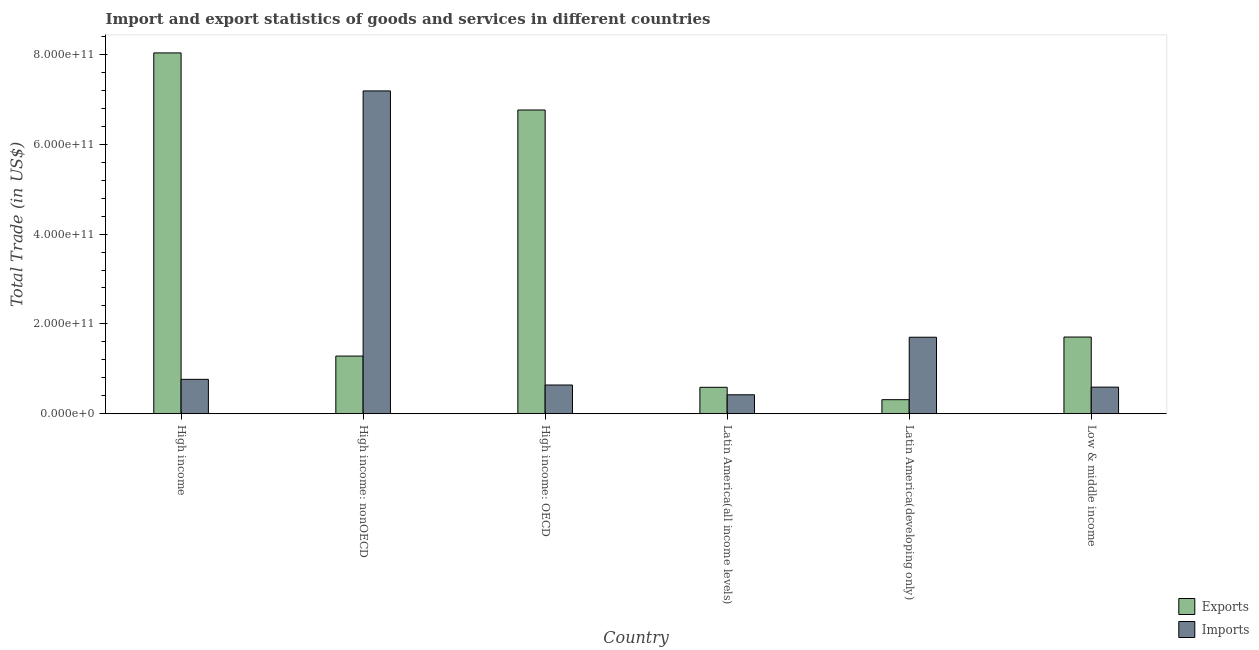Are the number of bars per tick equal to the number of legend labels?
Make the answer very short. Yes. Are the number of bars on each tick of the X-axis equal?
Provide a short and direct response. Yes. What is the imports of goods and services in Latin America(all income levels)?
Your response must be concise. 4.22e+1. Across all countries, what is the maximum export of goods and services?
Your answer should be compact. 8.03e+11. Across all countries, what is the minimum imports of goods and services?
Offer a very short reply. 4.22e+1. In which country was the imports of goods and services maximum?
Make the answer very short. High income: nonOECD. In which country was the imports of goods and services minimum?
Offer a very short reply. Latin America(all income levels). What is the total imports of goods and services in the graph?
Make the answer very short. 1.13e+12. What is the difference between the imports of goods and services in Latin America(all income levels) and that in Latin America(developing only)?
Offer a terse response. -1.28e+11. What is the difference between the export of goods and services in Latin America(developing only) and the imports of goods and services in High income: nonOECD?
Your answer should be compact. -6.87e+11. What is the average imports of goods and services per country?
Your response must be concise. 1.89e+11. What is the difference between the export of goods and services and imports of goods and services in High income?
Provide a succinct answer. 7.27e+11. What is the ratio of the imports of goods and services in High income: nonOECD to that in Low & middle income?
Give a very brief answer. 12.13. Is the imports of goods and services in High income less than that in Low & middle income?
Give a very brief answer. No. Is the difference between the export of goods and services in High income and High income: nonOECD greater than the difference between the imports of goods and services in High income and High income: nonOECD?
Offer a terse response. Yes. What is the difference between the highest and the second highest imports of goods and services?
Ensure brevity in your answer.  5.48e+11. What is the difference between the highest and the lowest export of goods and services?
Your answer should be compact. 7.72e+11. In how many countries, is the export of goods and services greater than the average export of goods and services taken over all countries?
Offer a terse response. 2. What does the 1st bar from the left in High income: nonOECD represents?
Give a very brief answer. Exports. What does the 2nd bar from the right in Latin America(developing only) represents?
Offer a very short reply. Exports. How many bars are there?
Keep it short and to the point. 12. How many countries are there in the graph?
Make the answer very short. 6. What is the difference between two consecutive major ticks on the Y-axis?
Your answer should be compact. 2.00e+11. Does the graph contain grids?
Your response must be concise. No. Where does the legend appear in the graph?
Your response must be concise. Bottom right. How many legend labels are there?
Give a very brief answer. 2. How are the legend labels stacked?
Make the answer very short. Vertical. What is the title of the graph?
Offer a terse response. Import and export statistics of goods and services in different countries. Does "Private consumption" appear as one of the legend labels in the graph?
Keep it short and to the point. No. What is the label or title of the X-axis?
Provide a succinct answer. Country. What is the label or title of the Y-axis?
Offer a terse response. Total Trade (in US$). What is the Total Trade (in US$) in Exports in High income?
Your answer should be very brief. 8.03e+11. What is the Total Trade (in US$) in Imports in High income?
Your response must be concise. 7.66e+1. What is the Total Trade (in US$) in Exports in High income: nonOECD?
Offer a very short reply. 1.28e+11. What is the Total Trade (in US$) in Imports in High income: nonOECD?
Your answer should be very brief. 7.19e+11. What is the Total Trade (in US$) of Exports in High income: OECD?
Offer a very short reply. 6.76e+11. What is the Total Trade (in US$) of Imports in High income: OECD?
Make the answer very short. 6.40e+1. What is the Total Trade (in US$) in Exports in Latin America(all income levels)?
Your answer should be very brief. 5.89e+1. What is the Total Trade (in US$) in Imports in Latin America(all income levels)?
Your answer should be compact. 4.22e+1. What is the Total Trade (in US$) in Exports in Latin America(developing only)?
Give a very brief answer. 3.13e+1. What is the Total Trade (in US$) of Imports in Latin America(developing only)?
Ensure brevity in your answer.  1.70e+11. What is the Total Trade (in US$) in Exports in Low & middle income?
Provide a short and direct response. 1.71e+11. What is the Total Trade (in US$) of Imports in Low & middle income?
Your answer should be very brief. 5.92e+1. Across all countries, what is the maximum Total Trade (in US$) of Exports?
Provide a short and direct response. 8.03e+11. Across all countries, what is the maximum Total Trade (in US$) of Imports?
Offer a very short reply. 7.19e+11. Across all countries, what is the minimum Total Trade (in US$) of Exports?
Offer a terse response. 3.13e+1. Across all countries, what is the minimum Total Trade (in US$) of Imports?
Your response must be concise. 4.22e+1. What is the total Total Trade (in US$) of Exports in the graph?
Your response must be concise. 1.87e+12. What is the total Total Trade (in US$) of Imports in the graph?
Your answer should be compact. 1.13e+12. What is the difference between the Total Trade (in US$) in Exports in High income and that in High income: nonOECD?
Your answer should be very brief. 6.75e+11. What is the difference between the Total Trade (in US$) in Imports in High income and that in High income: nonOECD?
Keep it short and to the point. -6.42e+11. What is the difference between the Total Trade (in US$) of Exports in High income and that in High income: OECD?
Ensure brevity in your answer.  1.27e+11. What is the difference between the Total Trade (in US$) of Imports in High income and that in High income: OECD?
Offer a terse response. 1.26e+1. What is the difference between the Total Trade (in US$) of Exports in High income and that in Latin America(all income levels)?
Make the answer very short. 7.44e+11. What is the difference between the Total Trade (in US$) in Imports in High income and that in Latin America(all income levels)?
Your answer should be compact. 3.44e+1. What is the difference between the Total Trade (in US$) in Exports in High income and that in Latin America(developing only)?
Keep it short and to the point. 7.72e+11. What is the difference between the Total Trade (in US$) of Imports in High income and that in Latin America(developing only)?
Keep it short and to the point. -9.38e+1. What is the difference between the Total Trade (in US$) in Exports in High income and that in Low & middle income?
Keep it short and to the point. 6.33e+11. What is the difference between the Total Trade (in US$) in Imports in High income and that in Low & middle income?
Your answer should be compact. 1.73e+1. What is the difference between the Total Trade (in US$) of Exports in High income: nonOECD and that in High income: OECD?
Offer a terse response. -5.48e+11. What is the difference between the Total Trade (in US$) of Imports in High income: nonOECD and that in High income: OECD?
Offer a terse response. 6.55e+11. What is the difference between the Total Trade (in US$) in Exports in High income: nonOECD and that in Latin America(all income levels)?
Keep it short and to the point. 6.95e+1. What is the difference between the Total Trade (in US$) of Imports in High income: nonOECD and that in Latin America(all income levels)?
Your response must be concise. 6.76e+11. What is the difference between the Total Trade (in US$) in Exports in High income: nonOECD and that in Latin America(developing only)?
Make the answer very short. 9.71e+1. What is the difference between the Total Trade (in US$) of Imports in High income: nonOECD and that in Latin America(developing only)?
Your answer should be compact. 5.48e+11. What is the difference between the Total Trade (in US$) of Exports in High income: nonOECD and that in Low & middle income?
Offer a very short reply. -4.24e+1. What is the difference between the Total Trade (in US$) in Imports in High income: nonOECD and that in Low & middle income?
Give a very brief answer. 6.59e+11. What is the difference between the Total Trade (in US$) of Exports in High income: OECD and that in Latin America(all income levels)?
Provide a short and direct response. 6.17e+11. What is the difference between the Total Trade (in US$) of Imports in High income: OECD and that in Latin America(all income levels)?
Ensure brevity in your answer.  2.18e+1. What is the difference between the Total Trade (in US$) of Exports in High income: OECD and that in Latin America(developing only)?
Provide a short and direct response. 6.45e+11. What is the difference between the Total Trade (in US$) of Imports in High income: OECD and that in Latin America(developing only)?
Give a very brief answer. -1.06e+11. What is the difference between the Total Trade (in US$) of Exports in High income: OECD and that in Low & middle income?
Offer a terse response. 5.05e+11. What is the difference between the Total Trade (in US$) of Imports in High income: OECD and that in Low & middle income?
Your answer should be compact. 4.72e+09. What is the difference between the Total Trade (in US$) in Exports in Latin America(all income levels) and that in Latin America(developing only)?
Provide a succinct answer. 2.76e+1. What is the difference between the Total Trade (in US$) in Imports in Latin America(all income levels) and that in Latin America(developing only)?
Ensure brevity in your answer.  -1.28e+11. What is the difference between the Total Trade (in US$) of Exports in Latin America(all income levels) and that in Low & middle income?
Your answer should be compact. -1.12e+11. What is the difference between the Total Trade (in US$) of Imports in Latin America(all income levels) and that in Low & middle income?
Give a very brief answer. -1.70e+1. What is the difference between the Total Trade (in US$) of Exports in Latin America(developing only) and that in Low & middle income?
Provide a short and direct response. -1.39e+11. What is the difference between the Total Trade (in US$) in Imports in Latin America(developing only) and that in Low & middle income?
Offer a very short reply. 1.11e+11. What is the difference between the Total Trade (in US$) of Exports in High income and the Total Trade (in US$) of Imports in High income: nonOECD?
Your answer should be compact. 8.46e+1. What is the difference between the Total Trade (in US$) in Exports in High income and the Total Trade (in US$) in Imports in High income: OECD?
Your answer should be very brief. 7.39e+11. What is the difference between the Total Trade (in US$) of Exports in High income and the Total Trade (in US$) of Imports in Latin America(all income levels)?
Keep it short and to the point. 7.61e+11. What is the difference between the Total Trade (in US$) in Exports in High income and the Total Trade (in US$) in Imports in Latin America(developing only)?
Keep it short and to the point. 6.33e+11. What is the difference between the Total Trade (in US$) in Exports in High income and the Total Trade (in US$) in Imports in Low & middle income?
Give a very brief answer. 7.44e+11. What is the difference between the Total Trade (in US$) of Exports in High income: nonOECD and the Total Trade (in US$) of Imports in High income: OECD?
Offer a very short reply. 6.44e+1. What is the difference between the Total Trade (in US$) in Exports in High income: nonOECD and the Total Trade (in US$) in Imports in Latin America(all income levels)?
Make the answer very short. 8.62e+1. What is the difference between the Total Trade (in US$) of Exports in High income: nonOECD and the Total Trade (in US$) of Imports in Latin America(developing only)?
Keep it short and to the point. -4.20e+1. What is the difference between the Total Trade (in US$) of Exports in High income: nonOECD and the Total Trade (in US$) of Imports in Low & middle income?
Your answer should be very brief. 6.91e+1. What is the difference between the Total Trade (in US$) of Exports in High income: OECD and the Total Trade (in US$) of Imports in Latin America(all income levels)?
Keep it short and to the point. 6.34e+11. What is the difference between the Total Trade (in US$) in Exports in High income: OECD and the Total Trade (in US$) in Imports in Latin America(developing only)?
Keep it short and to the point. 5.06e+11. What is the difference between the Total Trade (in US$) in Exports in High income: OECD and the Total Trade (in US$) in Imports in Low & middle income?
Provide a short and direct response. 6.17e+11. What is the difference between the Total Trade (in US$) in Exports in Latin America(all income levels) and the Total Trade (in US$) in Imports in Latin America(developing only)?
Offer a terse response. -1.11e+11. What is the difference between the Total Trade (in US$) in Exports in Latin America(all income levels) and the Total Trade (in US$) in Imports in Low & middle income?
Make the answer very short. -3.97e+08. What is the difference between the Total Trade (in US$) of Exports in Latin America(developing only) and the Total Trade (in US$) of Imports in Low & middle income?
Offer a very short reply. -2.79e+1. What is the average Total Trade (in US$) of Exports per country?
Provide a short and direct response. 3.11e+11. What is the average Total Trade (in US$) of Imports per country?
Make the answer very short. 1.89e+11. What is the difference between the Total Trade (in US$) in Exports and Total Trade (in US$) in Imports in High income?
Give a very brief answer. 7.27e+11. What is the difference between the Total Trade (in US$) in Exports and Total Trade (in US$) in Imports in High income: nonOECD?
Give a very brief answer. -5.90e+11. What is the difference between the Total Trade (in US$) in Exports and Total Trade (in US$) in Imports in High income: OECD?
Provide a short and direct response. 6.12e+11. What is the difference between the Total Trade (in US$) of Exports and Total Trade (in US$) of Imports in Latin America(all income levels)?
Your response must be concise. 1.66e+1. What is the difference between the Total Trade (in US$) in Exports and Total Trade (in US$) in Imports in Latin America(developing only)?
Ensure brevity in your answer.  -1.39e+11. What is the difference between the Total Trade (in US$) in Exports and Total Trade (in US$) in Imports in Low & middle income?
Ensure brevity in your answer.  1.12e+11. What is the ratio of the Total Trade (in US$) of Exports in High income to that in High income: nonOECD?
Your answer should be compact. 6.26. What is the ratio of the Total Trade (in US$) of Imports in High income to that in High income: nonOECD?
Provide a succinct answer. 0.11. What is the ratio of the Total Trade (in US$) of Exports in High income to that in High income: OECD?
Offer a terse response. 1.19. What is the ratio of the Total Trade (in US$) of Imports in High income to that in High income: OECD?
Keep it short and to the point. 1.2. What is the ratio of the Total Trade (in US$) in Exports in High income to that in Latin America(all income levels)?
Keep it short and to the point. 13.65. What is the ratio of the Total Trade (in US$) of Imports in High income to that in Latin America(all income levels)?
Offer a terse response. 1.81. What is the ratio of the Total Trade (in US$) of Exports in High income to that in Latin America(developing only)?
Offer a terse response. 25.66. What is the ratio of the Total Trade (in US$) of Imports in High income to that in Latin America(developing only)?
Keep it short and to the point. 0.45. What is the ratio of the Total Trade (in US$) of Exports in High income to that in Low & middle income?
Ensure brevity in your answer.  4.7. What is the ratio of the Total Trade (in US$) in Imports in High income to that in Low & middle income?
Your response must be concise. 1.29. What is the ratio of the Total Trade (in US$) in Exports in High income: nonOECD to that in High income: OECD?
Provide a short and direct response. 0.19. What is the ratio of the Total Trade (in US$) in Imports in High income: nonOECD to that in High income: OECD?
Give a very brief answer. 11.24. What is the ratio of the Total Trade (in US$) in Exports in High income: nonOECD to that in Latin America(all income levels)?
Your answer should be compact. 2.18. What is the ratio of the Total Trade (in US$) of Imports in High income: nonOECD to that in Latin America(all income levels)?
Make the answer very short. 17.03. What is the ratio of the Total Trade (in US$) in Exports in High income: nonOECD to that in Latin America(developing only)?
Offer a terse response. 4.1. What is the ratio of the Total Trade (in US$) in Imports in High income: nonOECD to that in Latin America(developing only)?
Make the answer very short. 4.22. What is the ratio of the Total Trade (in US$) of Exports in High income: nonOECD to that in Low & middle income?
Offer a terse response. 0.75. What is the ratio of the Total Trade (in US$) in Imports in High income: nonOECD to that in Low & middle income?
Provide a short and direct response. 12.13. What is the ratio of the Total Trade (in US$) of Exports in High income: OECD to that in Latin America(all income levels)?
Give a very brief answer. 11.49. What is the ratio of the Total Trade (in US$) of Imports in High income: OECD to that in Latin America(all income levels)?
Make the answer very short. 1.52. What is the ratio of the Total Trade (in US$) of Exports in High income: OECD to that in Latin America(developing only)?
Keep it short and to the point. 21.6. What is the ratio of the Total Trade (in US$) in Imports in High income: OECD to that in Latin America(developing only)?
Your answer should be very brief. 0.38. What is the ratio of the Total Trade (in US$) in Exports in High income: OECD to that in Low & middle income?
Offer a very short reply. 3.96. What is the ratio of the Total Trade (in US$) in Imports in High income: OECD to that in Low & middle income?
Offer a terse response. 1.08. What is the ratio of the Total Trade (in US$) in Exports in Latin America(all income levels) to that in Latin America(developing only)?
Make the answer very short. 1.88. What is the ratio of the Total Trade (in US$) of Imports in Latin America(all income levels) to that in Latin America(developing only)?
Provide a succinct answer. 0.25. What is the ratio of the Total Trade (in US$) of Exports in Latin America(all income levels) to that in Low & middle income?
Give a very brief answer. 0.34. What is the ratio of the Total Trade (in US$) of Imports in Latin America(all income levels) to that in Low & middle income?
Your response must be concise. 0.71. What is the ratio of the Total Trade (in US$) in Exports in Latin America(developing only) to that in Low & middle income?
Keep it short and to the point. 0.18. What is the ratio of the Total Trade (in US$) of Imports in Latin America(developing only) to that in Low & middle income?
Provide a succinct answer. 2.88. What is the difference between the highest and the second highest Total Trade (in US$) in Exports?
Provide a succinct answer. 1.27e+11. What is the difference between the highest and the second highest Total Trade (in US$) in Imports?
Your answer should be very brief. 5.48e+11. What is the difference between the highest and the lowest Total Trade (in US$) of Exports?
Your response must be concise. 7.72e+11. What is the difference between the highest and the lowest Total Trade (in US$) of Imports?
Provide a succinct answer. 6.76e+11. 